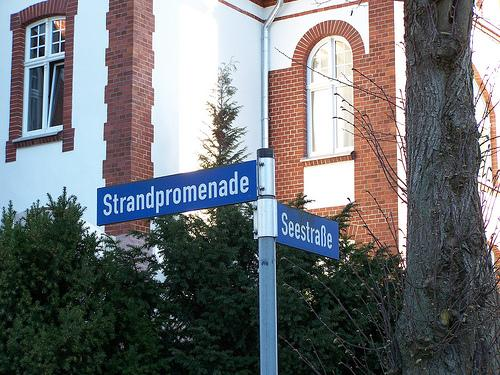Identify the main object in the image and describe any connected occurrences or items. The main object in the image is a blue street sign on a pole, and nearby items and occurrences include tree leaves, people playing frisbee, and building windows. What is the central object in the image, and what are the things happening around it? The image showcases a blue street sign on a pole, while other urban elements, like tree leaves, building windows, and people playing frisbee, are also present in the scene. Summarize the main element in the image and include any associated activities. The primary element of the image is a blue street sign on a pole, and nearby components include tree leaves, building windows, and frisbee players. Illustrate the main subject of the image, and mention its surrounding environment. A blue street sign on a pole with white letters takes center stage in the image, while windows on buildings, leaves on trees, and people engaged in a frisbee game fill the surrounding areas. Highlight the central characteristic of the image, mentioning any related items or events. The central characteristic of the image is a blue street sign on a pole, with various urban features like tree leaves, building windows, and frisbee players serving as additional highlights. Depict the primary subject of the image and its surroundings, including any activities. The image focuses on a blue street sign affixed to a pole, while its environment includes tree leaves, windows on buildings, and individuals playing a spirited game of frisbee. Could you succinctly describe the principal item in the picture and mention any related activities? The image primarily features a blue street sign on a pole, accompanied by various urban elements, like trees with leaves, buildings with windows, and frisbee-playing individuals. Can you briefly describe the primary focus of the image and any surrounding details? The main focus is a blue street sign with white letters on a pole, surrounded by elements such as tree leaves, building windows, and individuals playing frisbee. Explain the most noticeable feature in the image, along with any associated actions. A distinct blue street sign, mounted on a pole, stands out in the image, while other elements like leaves on trees, windows on buildings, and people playing with a white frisbee are also present. Provide a concise explanation of the central object in the image and its activity. A blue street sign on a pole with white lettering is displayed prominently in the scene, surrounded by various urban elements such as windows, trees, and frisbee players. 